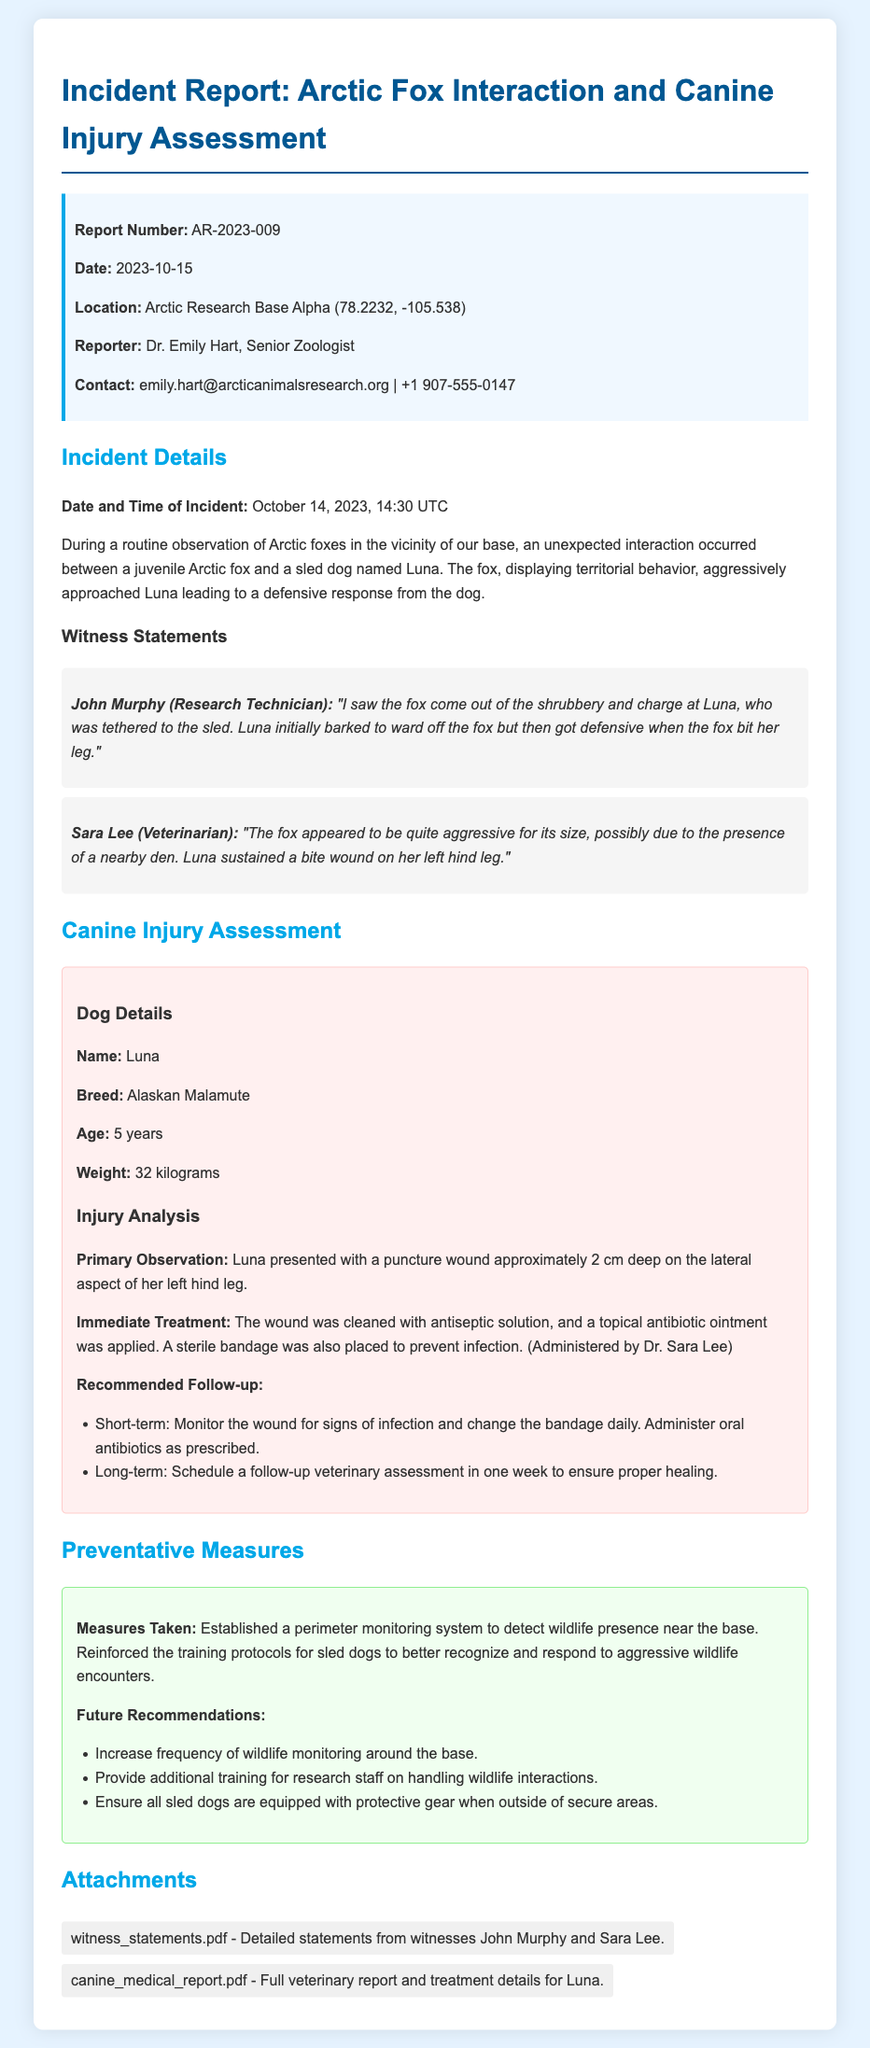What is the report number? The report number is mentioned at the beginning of the document under the info box section.
Answer: AR-2023-009 Who reported the incident? The name of the person who reported the incident is listed in the info box section of the document.
Answer: Dr. Emily Hart What date did the incident occur? The date and time of the incident are specified in the incident details section of the document.
Answer: October 14, 2023 What breed is the injured dog? The breed of the dog is provided in the canine injury assessment section under dog details.
Answer: Alaskan Malamute What was Luna's injury? The nature of the injury is described in the injury analysis part of the canine injury assessment.
Answer: Puncture wound What immediate treatment was applied? The immediate treatment for Luna's injury is outlined in the injury analysis section of the document.
Answer: Cleaned with antiseptic solution, topical antibiotic ointment What future recommendation is suggested for the sled dogs? Future recommendations for the sled dogs are listed in the preventative measures section of the document.
Answer: Protective gear when outside of secure areas How deep was the puncture wound? The depth of the puncture wound is specified in the injury analysis of the canine injury assessment.
Answer: 2 cm Which witness observed the incident? The witness statements section provides the names of individuals who witnessed the incident.
Answer: John Murphy 